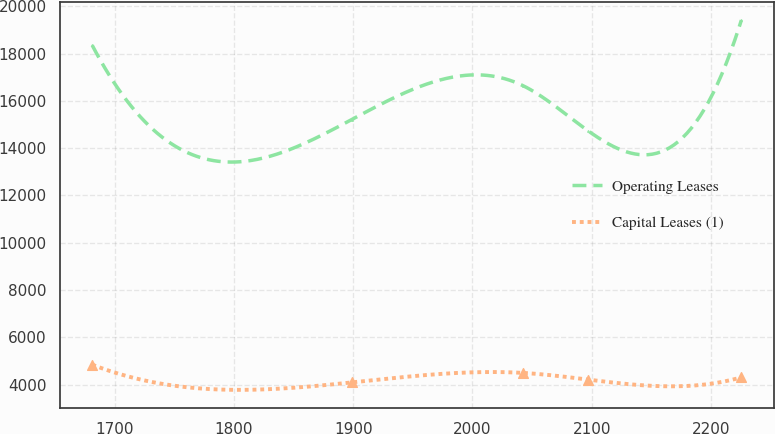Convert chart to OTSL. <chart><loc_0><loc_0><loc_500><loc_500><line_chart><ecel><fcel>Operating Leases<fcel>Capital Leases (1)<nl><fcel>1681.08<fcel>18349.5<fcel>4848.2<nl><fcel>1898.68<fcel>15208.5<fcel>4097.51<nl><fcel>2042.36<fcel>16643.8<fcel>4500.13<nl><fcel>2096.81<fcel>14741.3<fcel>4218.23<nl><fcel>2225.55<fcel>19412.7<fcel>4312.24<nl></chart> 